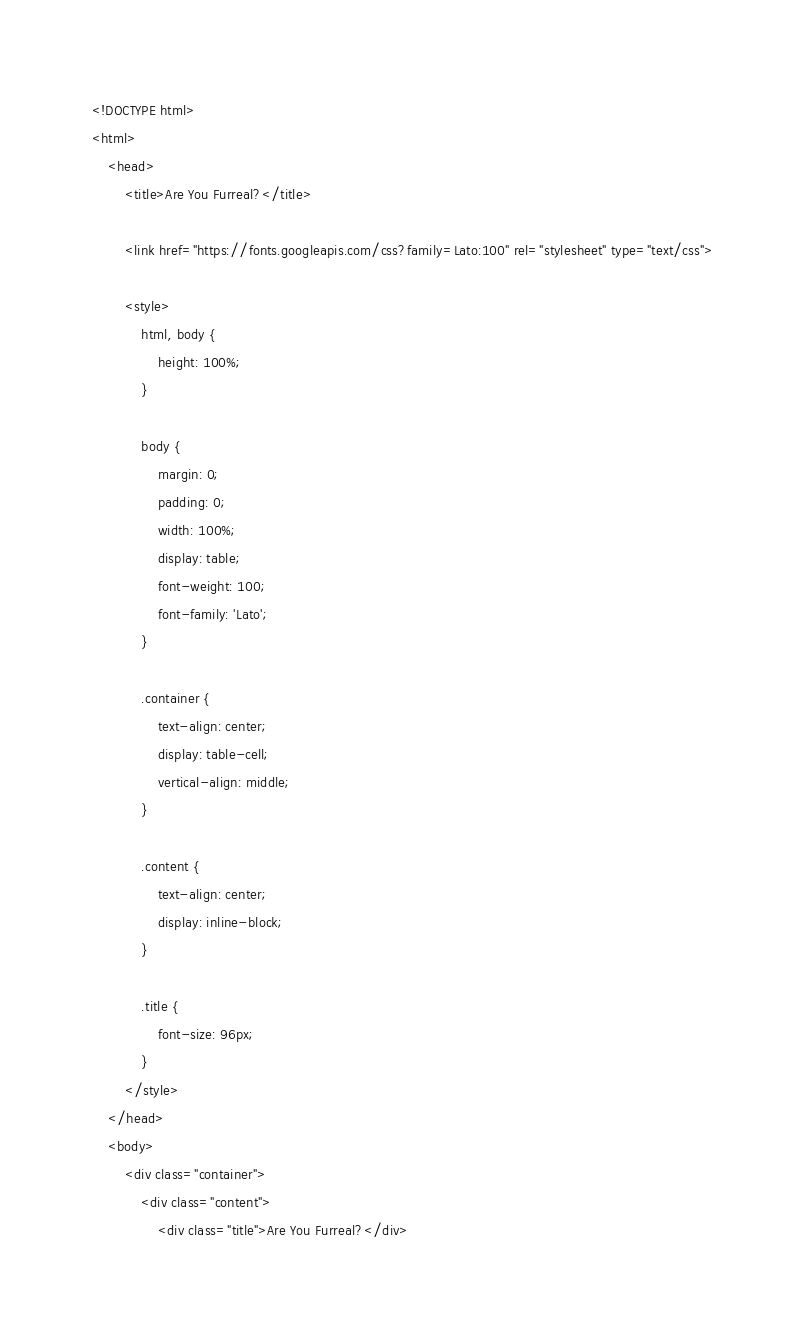Convert code to text. <code><loc_0><loc_0><loc_500><loc_500><_PHP_><!DOCTYPE html>
<html>
    <head>
        <title>Are You Furreal?</title>

        <link href="https://fonts.googleapis.com/css?family=Lato:100" rel="stylesheet" type="text/css">

        <style>
            html, body {
                height: 100%;
            }

            body {
                margin: 0;
                padding: 0;
                width: 100%;
                display: table;
                font-weight: 100;
                font-family: 'Lato';
            }

            .container {
                text-align: center;
                display: table-cell;
                vertical-align: middle;
            }

            .content {
                text-align: center;
                display: inline-block;
            }

            .title {
                font-size: 96px;
            }
        </style>
    </head>
    <body>
        <div class="container">
            <div class="content">
                <div class="title">Are You Furreal?</div></code> 